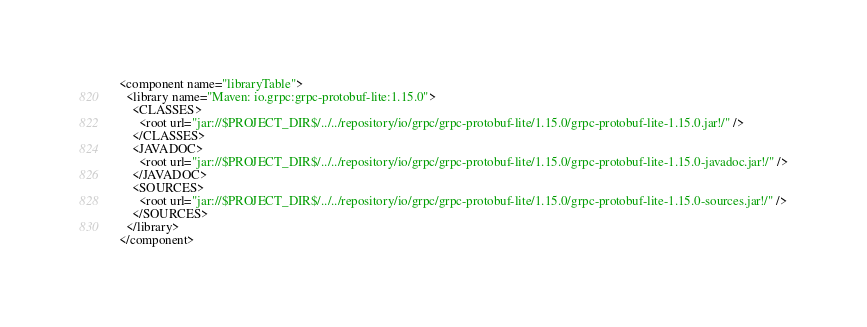Convert code to text. <code><loc_0><loc_0><loc_500><loc_500><_XML_><component name="libraryTable">
  <library name="Maven: io.grpc:grpc-protobuf-lite:1.15.0">
    <CLASSES>
      <root url="jar://$PROJECT_DIR$/../../repository/io/grpc/grpc-protobuf-lite/1.15.0/grpc-protobuf-lite-1.15.0.jar!/" />
    </CLASSES>
    <JAVADOC>
      <root url="jar://$PROJECT_DIR$/../../repository/io/grpc/grpc-protobuf-lite/1.15.0/grpc-protobuf-lite-1.15.0-javadoc.jar!/" />
    </JAVADOC>
    <SOURCES>
      <root url="jar://$PROJECT_DIR$/../../repository/io/grpc/grpc-protobuf-lite/1.15.0/grpc-protobuf-lite-1.15.0-sources.jar!/" />
    </SOURCES>
  </library>
</component></code> 